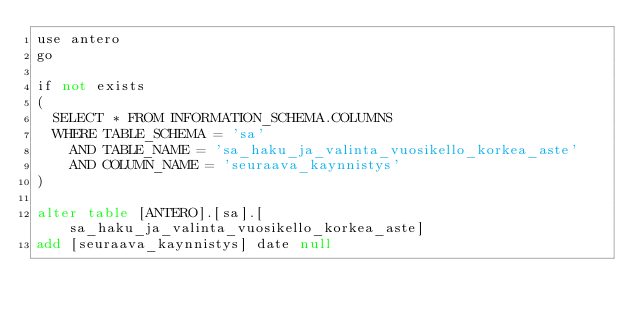<code> <loc_0><loc_0><loc_500><loc_500><_SQL_>use antero
go

if not exists 
(
  SELECT * FROM INFORMATION_SCHEMA.COLUMNS 
  WHERE TABLE_SCHEMA = 'sa' 
    AND TABLE_NAME = 'sa_haku_ja_valinta_vuosikello_korkea_aste' 
	AND COLUMN_NAME = 'seuraava_kaynnistys'
)

alter table [ANTERO].[sa].[sa_haku_ja_valinta_vuosikello_korkea_aste]
add [seuraava_kaynnistys] date null
</code> 